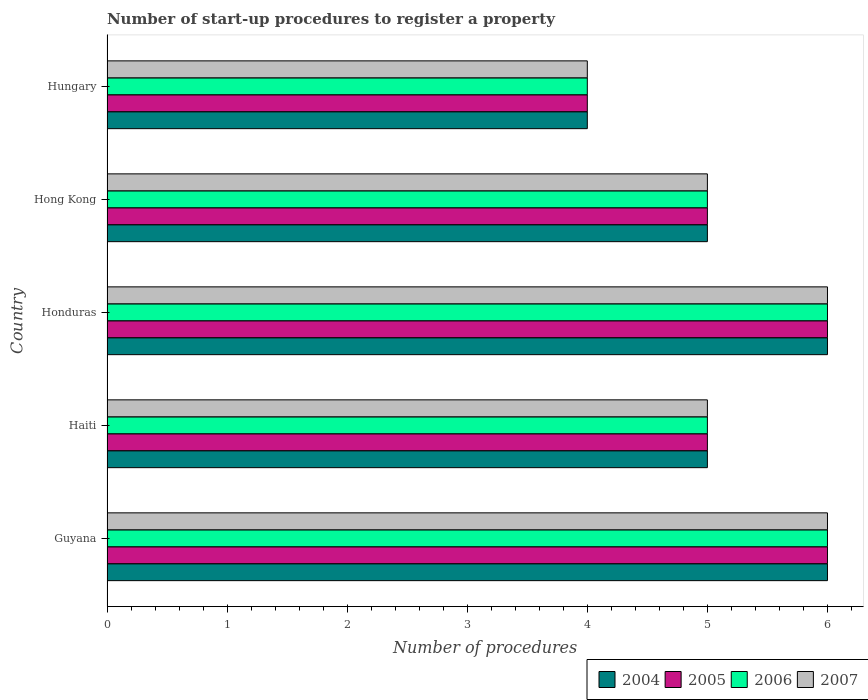How many different coloured bars are there?
Make the answer very short. 4. How many bars are there on the 2nd tick from the bottom?
Your answer should be compact. 4. What is the label of the 2nd group of bars from the top?
Offer a terse response. Hong Kong. In how many cases, is the number of bars for a given country not equal to the number of legend labels?
Your answer should be very brief. 0. What is the number of procedures required to register a property in 2007 in Hong Kong?
Keep it short and to the point. 5. Across all countries, what is the minimum number of procedures required to register a property in 2004?
Provide a succinct answer. 4. In which country was the number of procedures required to register a property in 2004 maximum?
Your answer should be compact. Guyana. In which country was the number of procedures required to register a property in 2007 minimum?
Keep it short and to the point. Hungary. What is the total number of procedures required to register a property in 2005 in the graph?
Offer a terse response. 26. What is the difference between the number of procedures required to register a property in 2005 in Honduras and the number of procedures required to register a property in 2007 in Hong Kong?
Your answer should be very brief. 1. Is the number of procedures required to register a property in 2004 in Guyana less than that in Hong Kong?
Provide a short and direct response. No. Is the difference between the number of procedures required to register a property in 2006 in Haiti and Honduras greater than the difference between the number of procedures required to register a property in 2005 in Haiti and Honduras?
Keep it short and to the point. No. What is the difference between the highest and the second highest number of procedures required to register a property in 2006?
Your answer should be very brief. 0. Is it the case that in every country, the sum of the number of procedures required to register a property in 2005 and number of procedures required to register a property in 2004 is greater than the sum of number of procedures required to register a property in 2007 and number of procedures required to register a property in 2006?
Provide a succinct answer. No. Is it the case that in every country, the sum of the number of procedures required to register a property in 2005 and number of procedures required to register a property in 2007 is greater than the number of procedures required to register a property in 2006?
Ensure brevity in your answer.  Yes. How many bars are there?
Give a very brief answer. 20. Are the values on the major ticks of X-axis written in scientific E-notation?
Your answer should be compact. No. Does the graph contain any zero values?
Provide a short and direct response. No. Where does the legend appear in the graph?
Keep it short and to the point. Bottom right. How many legend labels are there?
Keep it short and to the point. 4. How are the legend labels stacked?
Your answer should be compact. Horizontal. What is the title of the graph?
Your response must be concise. Number of start-up procedures to register a property. Does "1981" appear as one of the legend labels in the graph?
Offer a terse response. No. What is the label or title of the X-axis?
Provide a short and direct response. Number of procedures. What is the label or title of the Y-axis?
Provide a short and direct response. Country. What is the Number of procedures in 2004 in Guyana?
Give a very brief answer. 6. What is the Number of procedures in 2005 in Haiti?
Ensure brevity in your answer.  5. What is the Number of procedures in 2004 in Honduras?
Ensure brevity in your answer.  6. What is the Number of procedures in 2005 in Honduras?
Ensure brevity in your answer.  6. What is the Number of procedures of 2006 in Honduras?
Your answer should be compact. 6. What is the Number of procedures in 2004 in Hong Kong?
Your answer should be compact. 5. What is the Number of procedures in 2006 in Hong Kong?
Provide a succinct answer. 5. Across all countries, what is the maximum Number of procedures of 2004?
Your answer should be compact. 6. Across all countries, what is the maximum Number of procedures of 2007?
Keep it short and to the point. 6. Across all countries, what is the minimum Number of procedures of 2004?
Provide a short and direct response. 4. Across all countries, what is the minimum Number of procedures of 2006?
Provide a succinct answer. 4. Across all countries, what is the minimum Number of procedures in 2007?
Offer a very short reply. 4. What is the total Number of procedures in 2005 in the graph?
Ensure brevity in your answer.  26. What is the total Number of procedures of 2007 in the graph?
Keep it short and to the point. 26. What is the difference between the Number of procedures in 2004 in Guyana and that in Haiti?
Your response must be concise. 1. What is the difference between the Number of procedures in 2005 in Guyana and that in Haiti?
Provide a short and direct response. 1. What is the difference between the Number of procedures of 2006 in Guyana and that in Haiti?
Provide a succinct answer. 1. What is the difference between the Number of procedures of 2004 in Guyana and that in Hungary?
Give a very brief answer. 2. What is the difference between the Number of procedures of 2005 in Guyana and that in Hungary?
Offer a terse response. 2. What is the difference between the Number of procedures in 2006 in Guyana and that in Hungary?
Your response must be concise. 2. What is the difference between the Number of procedures of 2007 in Guyana and that in Hungary?
Ensure brevity in your answer.  2. What is the difference between the Number of procedures in 2004 in Haiti and that in Hong Kong?
Make the answer very short. 0. What is the difference between the Number of procedures in 2004 in Haiti and that in Hungary?
Provide a short and direct response. 1. What is the difference between the Number of procedures in 2007 in Haiti and that in Hungary?
Provide a succinct answer. 1. What is the difference between the Number of procedures of 2004 in Honduras and that in Hong Kong?
Give a very brief answer. 1. What is the difference between the Number of procedures in 2005 in Honduras and that in Hong Kong?
Ensure brevity in your answer.  1. What is the difference between the Number of procedures of 2007 in Honduras and that in Hong Kong?
Offer a terse response. 1. What is the difference between the Number of procedures of 2004 in Honduras and that in Hungary?
Your answer should be very brief. 2. What is the difference between the Number of procedures of 2006 in Honduras and that in Hungary?
Offer a terse response. 2. What is the difference between the Number of procedures of 2006 in Hong Kong and that in Hungary?
Keep it short and to the point. 1. What is the difference between the Number of procedures in 2007 in Hong Kong and that in Hungary?
Keep it short and to the point. 1. What is the difference between the Number of procedures of 2004 in Guyana and the Number of procedures of 2005 in Haiti?
Your answer should be compact. 1. What is the difference between the Number of procedures of 2004 in Guyana and the Number of procedures of 2006 in Haiti?
Provide a succinct answer. 1. What is the difference between the Number of procedures of 2004 in Guyana and the Number of procedures of 2007 in Haiti?
Give a very brief answer. 1. What is the difference between the Number of procedures of 2006 in Guyana and the Number of procedures of 2007 in Haiti?
Your response must be concise. 1. What is the difference between the Number of procedures of 2004 in Guyana and the Number of procedures of 2007 in Honduras?
Ensure brevity in your answer.  0. What is the difference between the Number of procedures in 2005 in Guyana and the Number of procedures in 2007 in Honduras?
Give a very brief answer. 0. What is the difference between the Number of procedures in 2006 in Guyana and the Number of procedures in 2007 in Honduras?
Offer a terse response. 0. What is the difference between the Number of procedures in 2004 in Guyana and the Number of procedures in 2005 in Hong Kong?
Give a very brief answer. 1. What is the difference between the Number of procedures in 2004 in Guyana and the Number of procedures in 2006 in Hong Kong?
Provide a succinct answer. 1. What is the difference between the Number of procedures of 2004 in Guyana and the Number of procedures of 2006 in Hungary?
Make the answer very short. 2. What is the difference between the Number of procedures in 2005 in Guyana and the Number of procedures in 2006 in Hungary?
Offer a terse response. 2. What is the difference between the Number of procedures of 2005 in Guyana and the Number of procedures of 2007 in Hungary?
Ensure brevity in your answer.  2. What is the difference between the Number of procedures in 2006 in Guyana and the Number of procedures in 2007 in Hungary?
Give a very brief answer. 2. What is the difference between the Number of procedures of 2004 in Haiti and the Number of procedures of 2005 in Honduras?
Offer a very short reply. -1. What is the difference between the Number of procedures in 2004 in Haiti and the Number of procedures in 2007 in Honduras?
Your answer should be compact. -1. What is the difference between the Number of procedures in 2005 in Haiti and the Number of procedures in 2006 in Honduras?
Offer a terse response. -1. What is the difference between the Number of procedures of 2004 in Haiti and the Number of procedures of 2005 in Hong Kong?
Provide a short and direct response. 0. What is the difference between the Number of procedures of 2004 in Haiti and the Number of procedures of 2007 in Hong Kong?
Provide a short and direct response. 0. What is the difference between the Number of procedures of 2005 in Haiti and the Number of procedures of 2006 in Hong Kong?
Give a very brief answer. 0. What is the difference between the Number of procedures of 2005 in Haiti and the Number of procedures of 2007 in Hong Kong?
Your answer should be compact. 0. What is the difference between the Number of procedures in 2004 in Haiti and the Number of procedures in 2006 in Hungary?
Your answer should be compact. 1. What is the difference between the Number of procedures of 2004 in Honduras and the Number of procedures of 2006 in Hong Kong?
Your response must be concise. 1. What is the difference between the Number of procedures of 2005 in Honduras and the Number of procedures of 2006 in Hong Kong?
Your response must be concise. 1. What is the difference between the Number of procedures of 2005 in Honduras and the Number of procedures of 2007 in Hong Kong?
Your response must be concise. 1. What is the difference between the Number of procedures in 2006 in Honduras and the Number of procedures in 2007 in Hong Kong?
Make the answer very short. 1. What is the difference between the Number of procedures of 2005 in Honduras and the Number of procedures of 2007 in Hungary?
Make the answer very short. 2. What is the difference between the Number of procedures of 2006 in Honduras and the Number of procedures of 2007 in Hungary?
Keep it short and to the point. 2. What is the difference between the Number of procedures in 2004 in Hong Kong and the Number of procedures in 2006 in Hungary?
Provide a succinct answer. 1. What is the difference between the Number of procedures of 2004 in Hong Kong and the Number of procedures of 2007 in Hungary?
Your answer should be very brief. 1. What is the difference between the Number of procedures in 2006 in Hong Kong and the Number of procedures in 2007 in Hungary?
Your answer should be very brief. 1. What is the average Number of procedures in 2004 per country?
Your response must be concise. 5.2. What is the average Number of procedures in 2006 per country?
Your response must be concise. 5.2. What is the difference between the Number of procedures in 2004 and Number of procedures in 2005 in Guyana?
Provide a succinct answer. 0. What is the difference between the Number of procedures of 2004 and Number of procedures of 2007 in Guyana?
Offer a very short reply. 0. What is the difference between the Number of procedures in 2005 and Number of procedures in 2007 in Guyana?
Keep it short and to the point. 0. What is the difference between the Number of procedures in 2004 and Number of procedures in 2007 in Haiti?
Your response must be concise. 0. What is the difference between the Number of procedures of 2005 and Number of procedures of 2007 in Haiti?
Your response must be concise. 0. What is the difference between the Number of procedures in 2006 and Number of procedures in 2007 in Haiti?
Offer a terse response. 0. What is the difference between the Number of procedures of 2004 and Number of procedures of 2005 in Honduras?
Offer a terse response. 0. What is the difference between the Number of procedures of 2004 and Number of procedures of 2005 in Hong Kong?
Your answer should be very brief. 0. What is the difference between the Number of procedures in 2004 and Number of procedures in 2007 in Hong Kong?
Your answer should be very brief. 0. What is the difference between the Number of procedures of 2006 and Number of procedures of 2007 in Hong Kong?
Keep it short and to the point. 0. What is the difference between the Number of procedures of 2004 and Number of procedures of 2007 in Hungary?
Offer a very short reply. 0. What is the difference between the Number of procedures in 2005 and Number of procedures in 2006 in Hungary?
Give a very brief answer. 0. What is the ratio of the Number of procedures in 2004 in Guyana to that in Haiti?
Your answer should be compact. 1.2. What is the ratio of the Number of procedures of 2005 in Guyana to that in Haiti?
Give a very brief answer. 1.2. What is the ratio of the Number of procedures of 2007 in Guyana to that in Haiti?
Your response must be concise. 1.2. What is the ratio of the Number of procedures in 2005 in Guyana to that in Honduras?
Give a very brief answer. 1. What is the ratio of the Number of procedures of 2006 in Guyana to that in Honduras?
Your answer should be very brief. 1. What is the ratio of the Number of procedures in 2004 in Guyana to that in Hong Kong?
Offer a very short reply. 1.2. What is the ratio of the Number of procedures of 2007 in Guyana to that in Hong Kong?
Provide a succinct answer. 1.2. What is the ratio of the Number of procedures of 2007 in Guyana to that in Hungary?
Offer a very short reply. 1.5. What is the ratio of the Number of procedures in 2007 in Haiti to that in Honduras?
Your response must be concise. 0.83. What is the ratio of the Number of procedures of 2004 in Haiti to that in Hong Kong?
Give a very brief answer. 1. What is the ratio of the Number of procedures in 2005 in Haiti to that in Hong Kong?
Your answer should be very brief. 1. What is the ratio of the Number of procedures in 2006 in Haiti to that in Hong Kong?
Keep it short and to the point. 1. What is the ratio of the Number of procedures in 2007 in Haiti to that in Hong Kong?
Offer a terse response. 1. What is the ratio of the Number of procedures of 2005 in Haiti to that in Hungary?
Keep it short and to the point. 1.25. What is the ratio of the Number of procedures of 2006 in Haiti to that in Hungary?
Provide a short and direct response. 1.25. What is the ratio of the Number of procedures in 2007 in Haiti to that in Hungary?
Keep it short and to the point. 1.25. What is the ratio of the Number of procedures in 2005 in Honduras to that in Hong Kong?
Make the answer very short. 1.2. What is the ratio of the Number of procedures in 2006 in Honduras to that in Hong Kong?
Make the answer very short. 1.2. What is the ratio of the Number of procedures of 2005 in Honduras to that in Hungary?
Ensure brevity in your answer.  1.5. What is the ratio of the Number of procedures of 2007 in Honduras to that in Hungary?
Provide a succinct answer. 1.5. What is the ratio of the Number of procedures of 2004 in Hong Kong to that in Hungary?
Ensure brevity in your answer.  1.25. What is the ratio of the Number of procedures of 2005 in Hong Kong to that in Hungary?
Make the answer very short. 1.25. What is the difference between the highest and the second highest Number of procedures of 2004?
Keep it short and to the point. 0. What is the difference between the highest and the second highest Number of procedures in 2007?
Ensure brevity in your answer.  0. What is the difference between the highest and the lowest Number of procedures of 2007?
Offer a terse response. 2. 